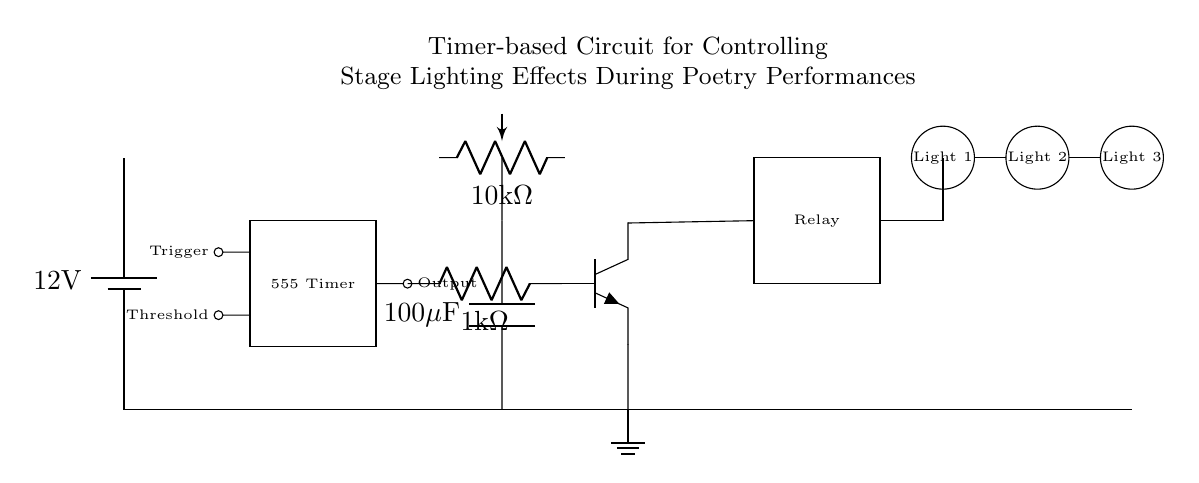What type of timer is used in this circuit? The circuit employs a 555 Timer, indicated by the rectangle labeled "555 Timer". This is a common integrated circuit used for timing applications.
Answer: 555 Timer What is the value of the potentiometer in this circuit? The circuit includes a potentiometer with a value of 10 kilohms, shown next to the associated symbol in the schematic.
Answer: 10 kilohms How many stage lights are controlled by this circuit? There are three stage lights present as indicated by three circles labeled "Light 1", "Light 2", and "Light 3" in the diagram.
Answer: Three What component is used to control the stage lights? A relay is used for controlling the stage lights as shown by the rectangle labeled "Relay" in the circuit.
Answer: Relay How is the timing of the circuit adjusted? The timing can be adjusted using the 10 kilohm potentiometer, which is connected in combination with the capacitor. This controls the timing interval for the 555 Timer.
Answer: Potentiometer What is the value of the capacitor used for timing? The circuit specifies a capacitor with a value of 100 microfarads, indicated by the labeling near the capacitor symbol.
Answer: 100 microfarads What role does the transistor play in this circuit? The transistor functions as a switch, allowing the relay (and thus the stage lights) to be controlled by the output of the 555 Timer based on the triggering signal.
Answer: Switch 